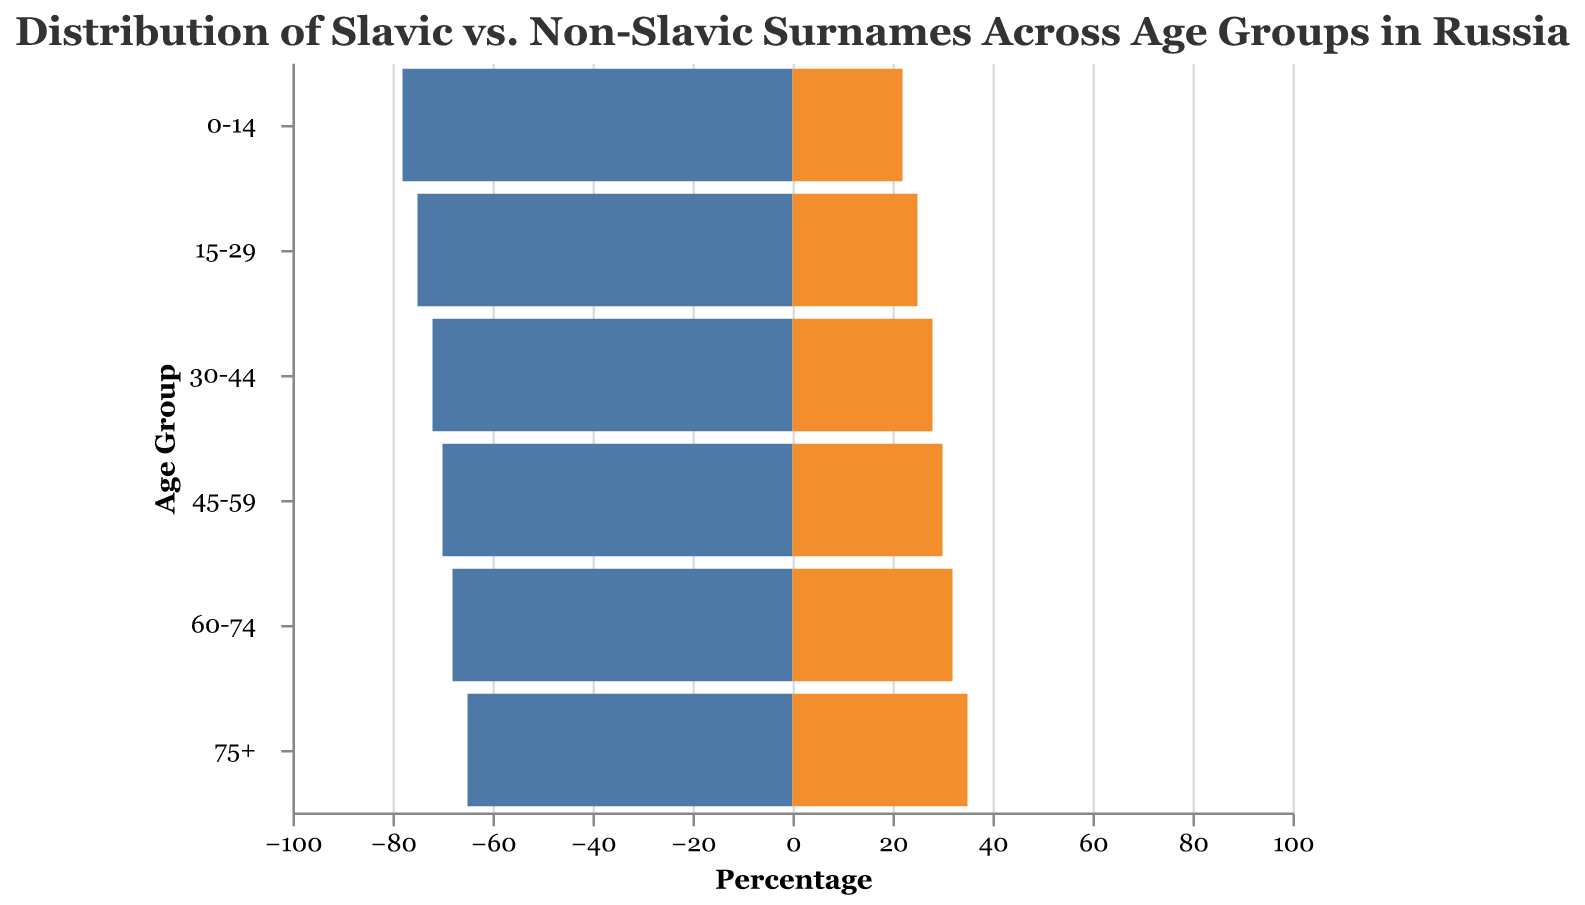What is the overall trend in the percentage of Slavic surnames as age increases? As age increases, the percentage of people with Slavic surnames decreases. This is seen by comparing the age groups from 0-14 (78%) to 75+ (65%).
Answer: The percentage of Slavic surnames decreases with age In which age group is the percentage of non-Slavic surnames the highest? The percentage of non-Slavic surnames is highest in the 75+ age group at 35%. This value is the largest among all age groups for non-Slavic surnames.
Answer: 75+ What is the difference in the percentage of Slavic surnames between the youngest and oldest age groups? The youngest age group (0-14) has 78% Slavic surnames, and the oldest age group (75+) has 65% Slavic surnames. The difference is 78% - 65% = 13%.
Answer: 13% How does the percentage of non-Slavic surnames change from the 15-29 age group to the 30-44 age group? The 15-29 age group has 25% non-Slavic surnames, and the 30-44 age group has 28%. The percentage increases by 3%.
Answer: Increases by 3% What is the sum of the percentages of Slavic and non-Slavic surnames for the 45-59 age group? For the 45-59 age group, the percentage of Slavic surnames is 70% and non-Slavic surnames is 30%. The sum is 70% + 30% = 100%.
Answer: 100% Which age group has the closest percentage of Slavic and non-Slavic surnames? The 75+ age group has 65% Slavic surnames and 35% non-Slavic surnames, with a difference of 65% - 35% = 30%, which is closer as compared to other age groups.
Answer: 75+ Among the given age groups, where is the percentage of Slavic surnames less than 70%? Reviewing the data, only the age group 75+ has less than 70% Slavic surnames, specifically 65%.
Answer: 75+ Which age group sees the largest decrease in the percentage of Slavic surnames compared to the previous group? The largest decrease occurs between the 60-74 and 75+ age groups where the percentage of Slavic surnames drops from 68% to 65%, a 3% decrease.
Answer: 75+ By how much does the percentage of non-Slavic surnames increase from 45-59 to 60-74 age group? In the 45-59 age group, the percentage of non-Slavic surnames is 30%, and in the 60-74 age group it is 32%. The increase is 32% - 30% = 2%.
Answer: Increases by 2% How does the balance between Slavic and non-Slavic surnames change as the population ages? As the population ages, the balance shifts towards a higher percentage of non-Slavic surnames. The percentage of Slavic surnames decreases while the percentage of non-Slavic surnames increases in older age groups.
Answer: The balance shifts towards non-Slavic surnames 